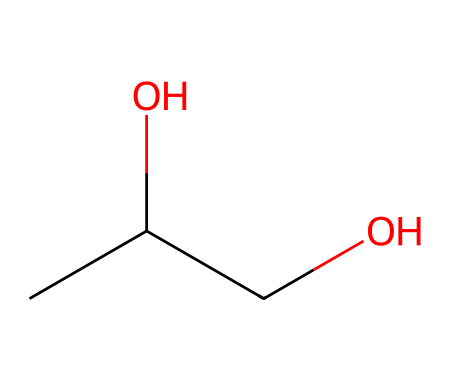What is the name of this chemical? The SMILES representation CC(O)CO corresponds to the structure of glycerol, which is a simple polyol compound.
Answer: glycerol How many carbon atoms are in the molecule? In the SMILES representation CC(O)CO, there are three carbon atoms denoted by the letters 'C'.
Answer: 3 How many hydroxyl (–OH) groups does this molecule have? The molecule has two hydroxyl groups, indicated by the two 'O' atoms in the structure where they are attached to carbon atoms (C(O)).
Answer: 2 Is this compound soluble in water? Given that glycerol is a small alcohol with multiple hydroxyl groups, it is soluble in water due to its ability to form hydrogen bonds.
Answer: yes What type of chemical is represented by this SMILES? The presence of multiple hydroxyl groups identifies it as an alcohol, which characterizes it among organic compounds.
Answer: alcohol What physical state is this chemical most likely to be found in at room temperature? Glycerol, being a small alcohol with a relatively low molecular weight, is typically a viscous liquid at room temperature.
Answer: liquid Does this chemical have any potential applications in concerts? Glycerol is often used in artificial fog machines due to its properties as a humectant, aiding in the production of fog effects for concerts.
Answer: yes 